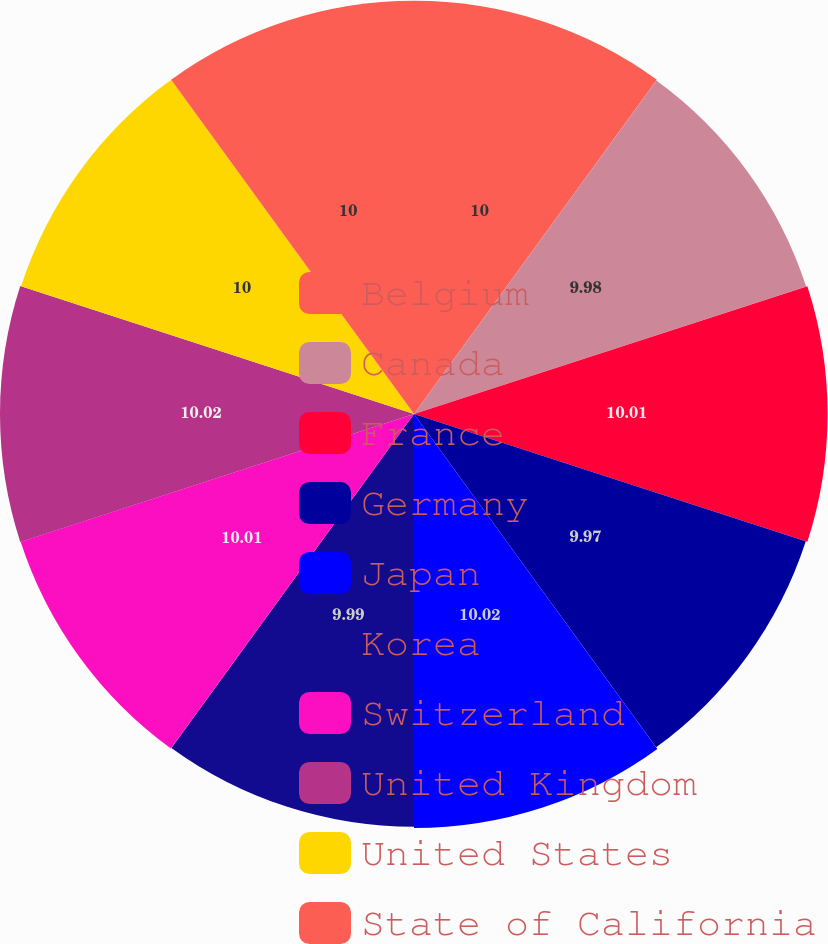<chart> <loc_0><loc_0><loc_500><loc_500><pie_chart><fcel>Belgium<fcel>Canada<fcel>France<fcel>Germany<fcel>Japan<fcel>Korea<fcel>Switzerland<fcel>United Kingdom<fcel>United States<fcel>State of California<nl><fcel>10.0%<fcel>9.98%<fcel>10.01%<fcel>9.97%<fcel>10.02%<fcel>9.99%<fcel>10.01%<fcel>10.02%<fcel>10.0%<fcel>10.0%<nl></chart> 